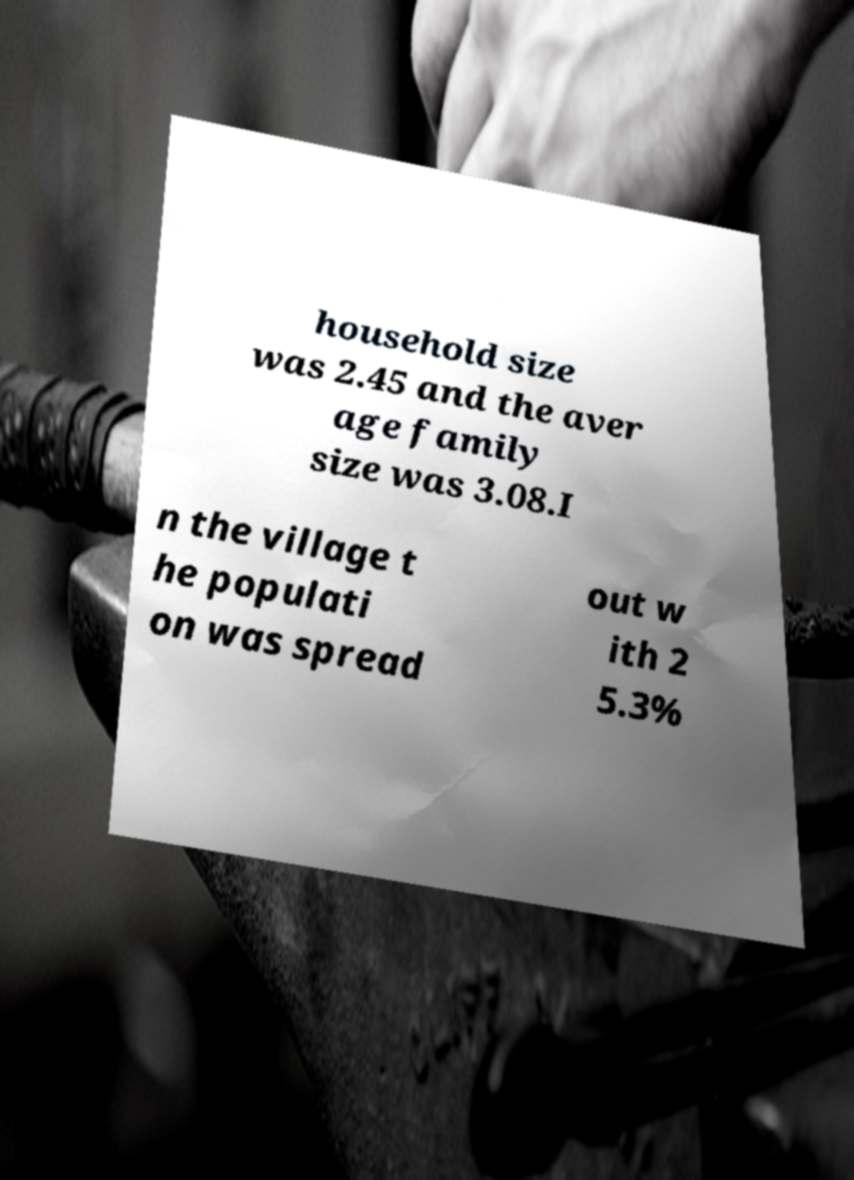Could you extract and type out the text from this image? household size was 2.45 and the aver age family size was 3.08.I n the village t he populati on was spread out w ith 2 5.3% 